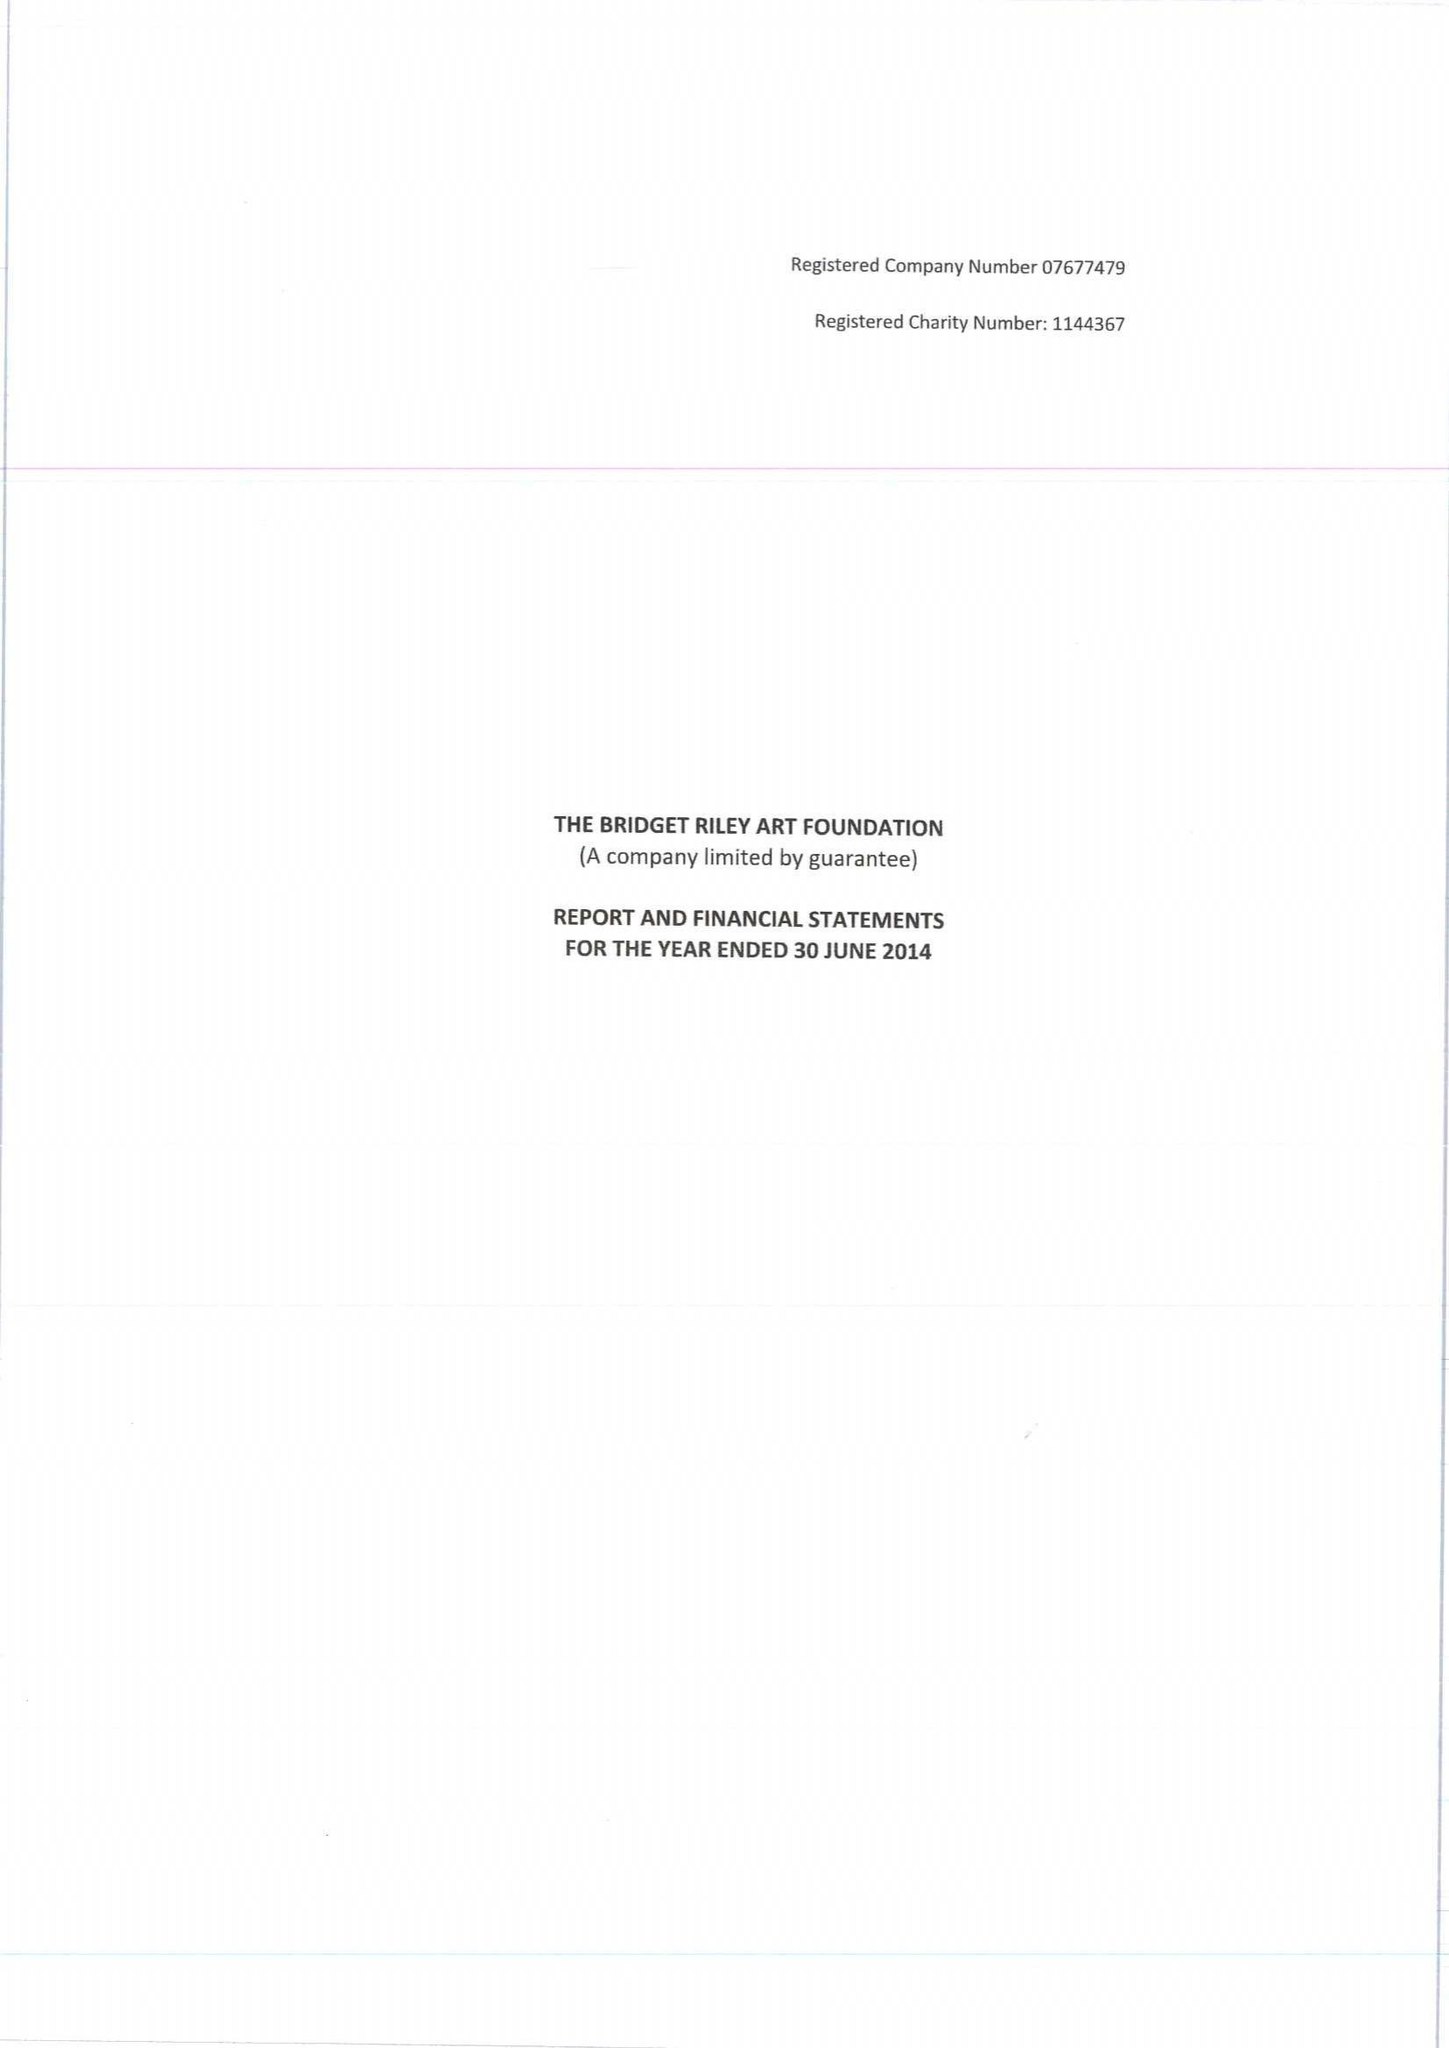What is the value for the income_annually_in_british_pounds?
Answer the question using a single word or phrase. 562251.00 